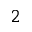Convert formula to latex. <formula><loc_0><loc_0><loc_500><loc_500>^ { 2 }</formula> 